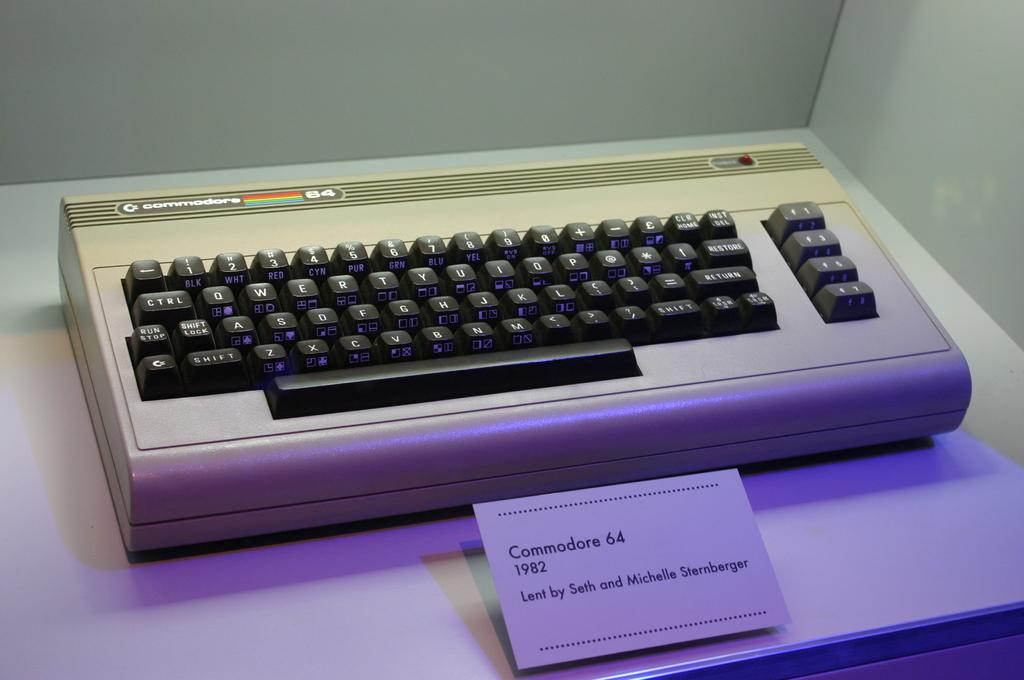<image>
Summarize the visual content of the image. A Commodore 64 computer and keyboard from 1982. 